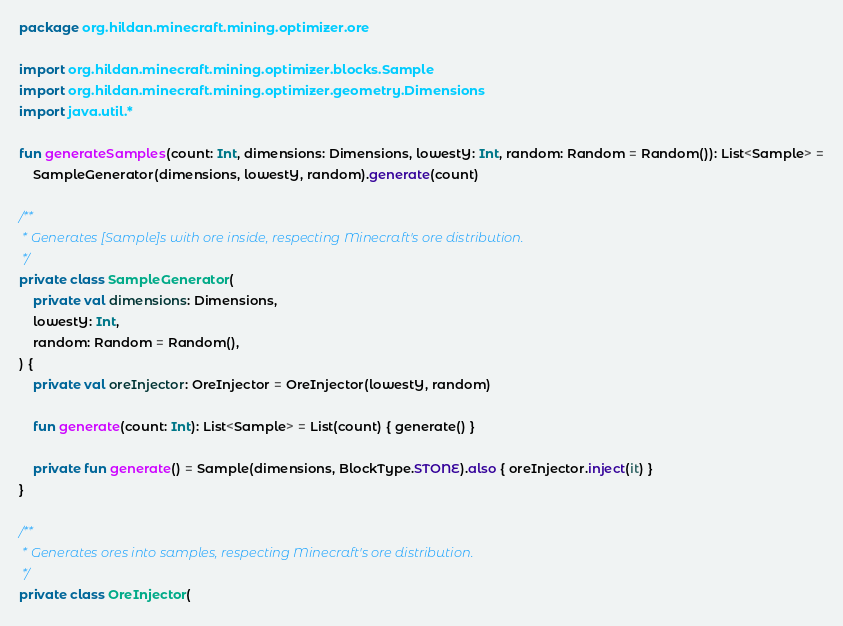Convert code to text. <code><loc_0><loc_0><loc_500><loc_500><_Kotlin_>package org.hildan.minecraft.mining.optimizer.ore

import org.hildan.minecraft.mining.optimizer.blocks.Sample
import org.hildan.minecraft.mining.optimizer.geometry.Dimensions
import java.util.*

fun generateSamples(count: Int, dimensions: Dimensions, lowestY: Int, random: Random = Random()): List<Sample> =
    SampleGenerator(dimensions, lowestY, random).generate(count)

/**
 * Generates [Sample]s with ore inside, respecting Minecraft's ore distribution.
 */
private class SampleGenerator(
    private val dimensions: Dimensions,
    lowestY: Int,
    random: Random = Random(),
) {
    private val oreInjector: OreInjector = OreInjector(lowestY, random)

    fun generate(count: Int): List<Sample> = List(count) { generate() }

    private fun generate() = Sample(dimensions, BlockType.STONE).also { oreInjector.inject(it) }
}

/**
 * Generates ores into samples, respecting Minecraft's ore distribution.
 */
private class OreInjector(</code> 